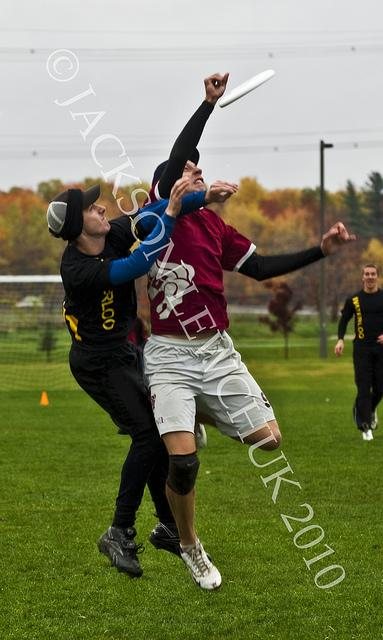What might stop you from using this image in a commercial capacity? text 